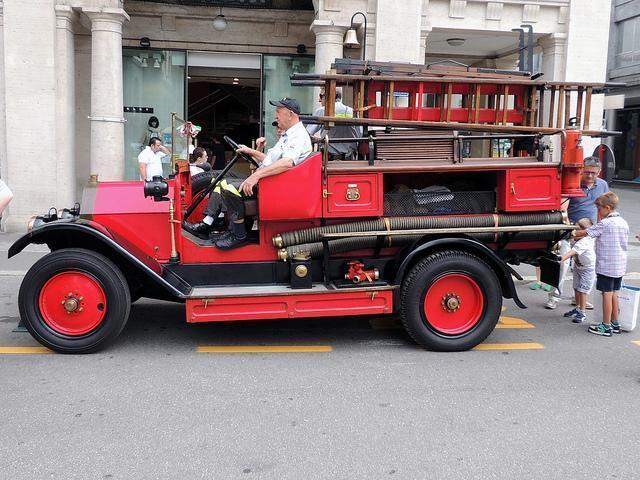How many people are there?
Give a very brief answer. 2. 